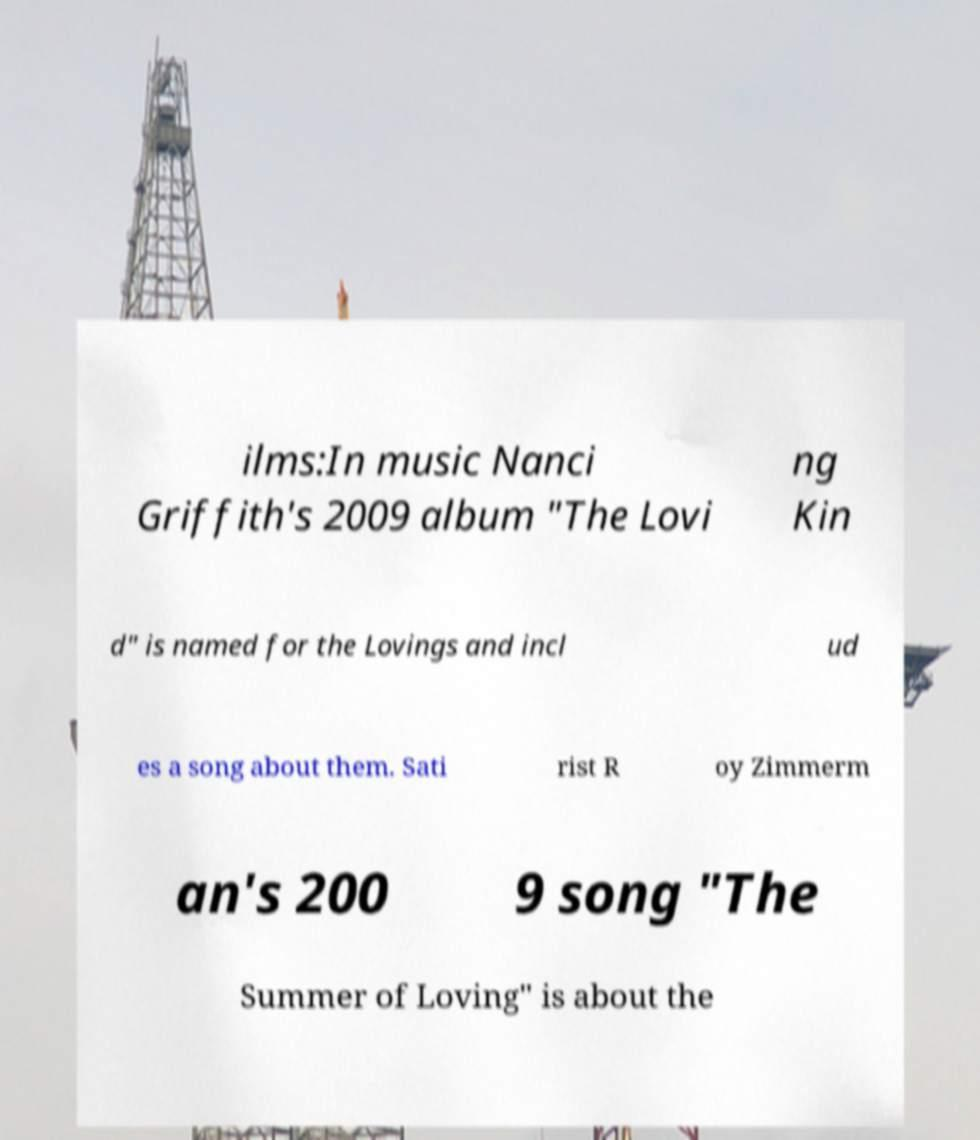Can you accurately transcribe the text from the provided image for me? ilms:In music Nanci Griffith's 2009 album "The Lovi ng Kin d" is named for the Lovings and incl ud es a song about them. Sati rist R oy Zimmerm an's 200 9 song "The Summer of Loving" is about the 